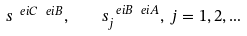Convert formula to latex. <formula><loc_0><loc_0><loc_500><loc_500>s ^ { \ e i C \ e i B } , \quad s _ { j } ^ { \ e i B \ e i A } , \, j = 1 , 2 , \dots</formula> 